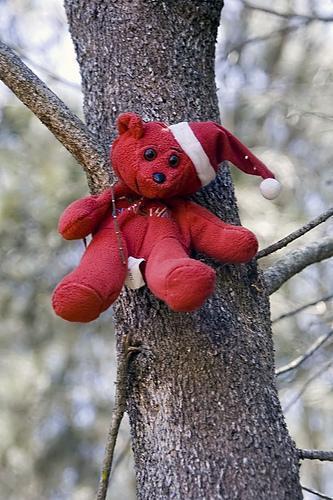How many umbrellas are there?
Give a very brief answer. 0. 